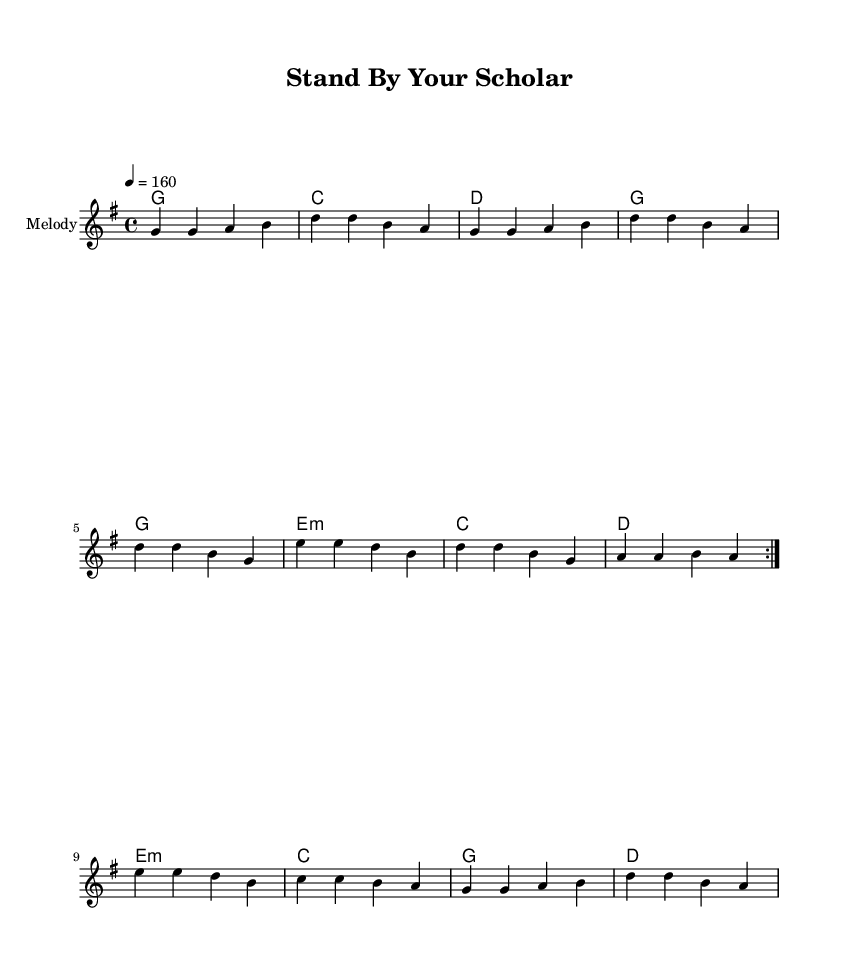What is the key signature of this music? The key signature is G major, which has one sharp (F#). This can be identified by looking at the signature at the beginning of the staff.
Answer: G major What is the time signature of this piece? The time signature is 4/4, indicated at the beginning of the music, which shows that there are four beats in each measure.
Answer: 4/4 What is the tempo marking of the score? The tempo marking is 160 beats per minute, indicated in the score as "4 = 160." This tells the musician the speed at which to play the piece.
Answer: 160 How many times is the first section repeated? The first section is repeated twice, as indicated by the "volta" markings. This is shown in the score before the first repeat bracket.
Answer: 2 What is the first chord in the piece? The first chord in the piece is G major, as observed in the chord names section at the beginning of the score, under the melody notes.
Answer: G Which measure has the only E minor chord? The E minor chord appears in the sequence and is the last chord of the first half at measure 8 (in the repetitive section). It can be located directly above the notes in the score.
Answer: Measure 8 